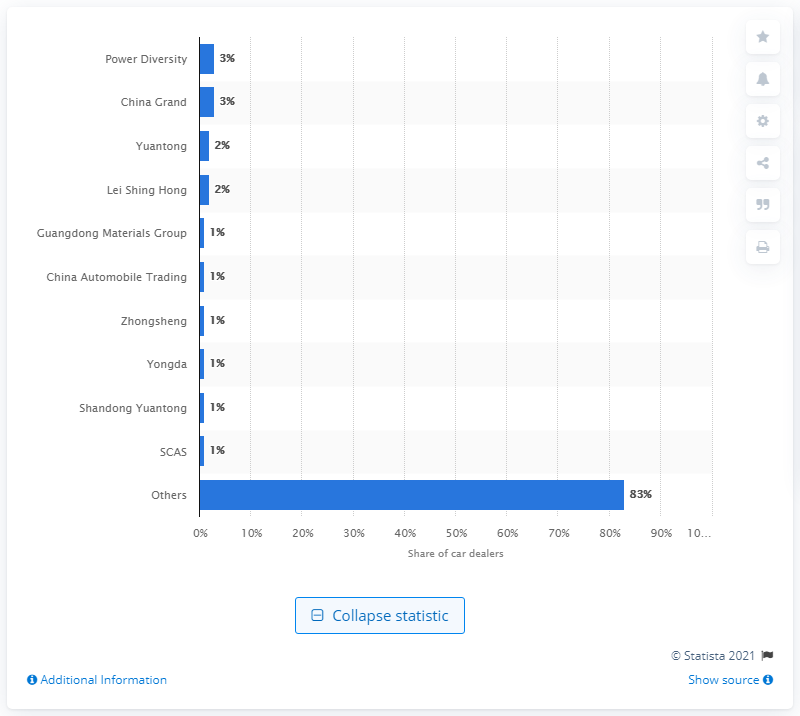List a handful of essential elements in this visual. In 2009, the car dealer with the largest market share in China was Power Diversity. 